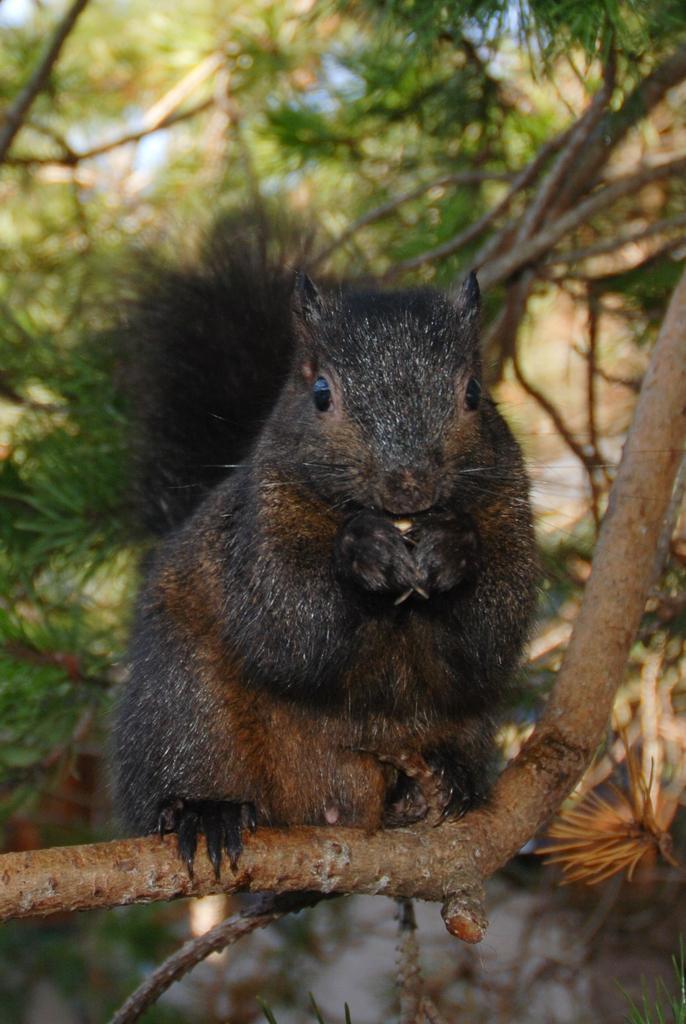Could you give a brief overview of what you see in this image? In this image I can see a squirrel on a branch. In the background I can see trees. 